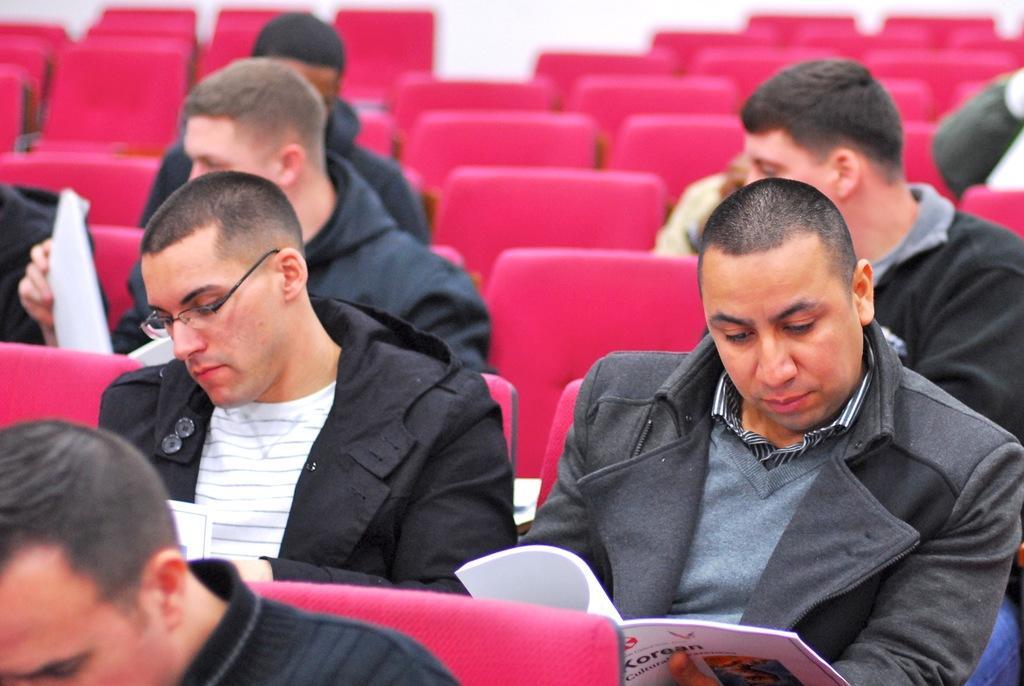Can you describe this image briefly? In this picture we can see a group of people and they are sitting on chairs and few people are holding books. 